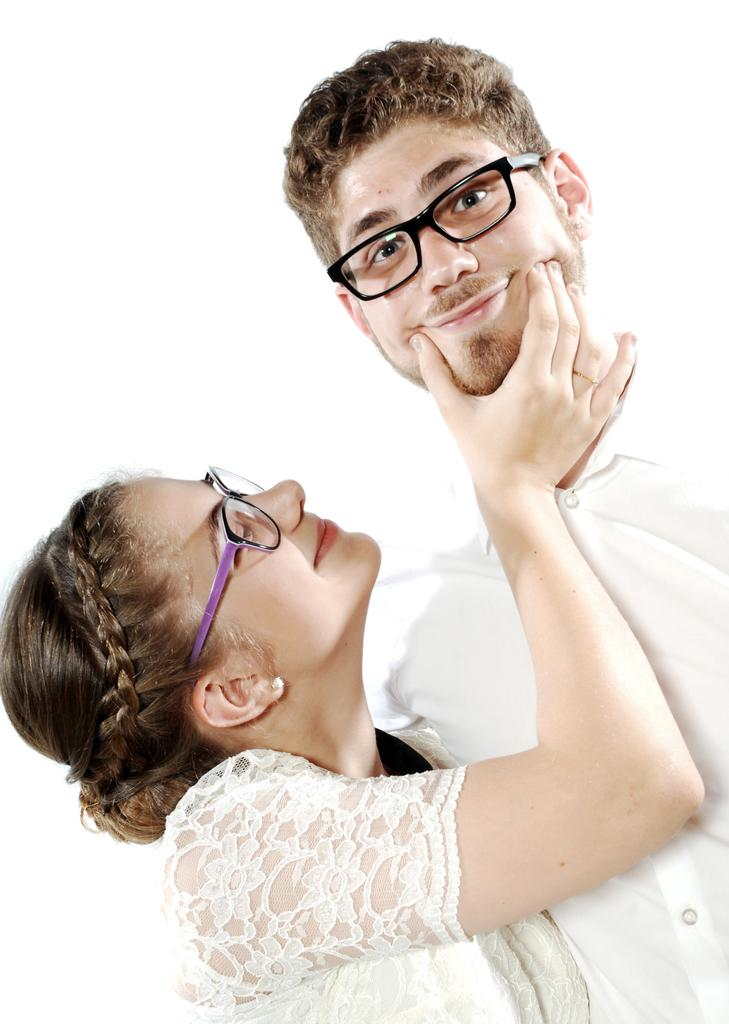What is the gender of the person in the image? There is a man in the image. What is the man doing in the image? The man is smiling. What accessory is the man wearing in the image? The man is wearing spectacles. Can you describe the woman in the image? There is a woman in the image, and she is also smiling. What accessory is the woman wearing in the image? The woman is wearing spectacles. What is the color of the background in the image? The background of the image is white in color. What type of rest is the achiever taking in the image? There is no reference to an achiever or rest in the image; it simply features a man and a woman, both smiling and wearing spectacles. 